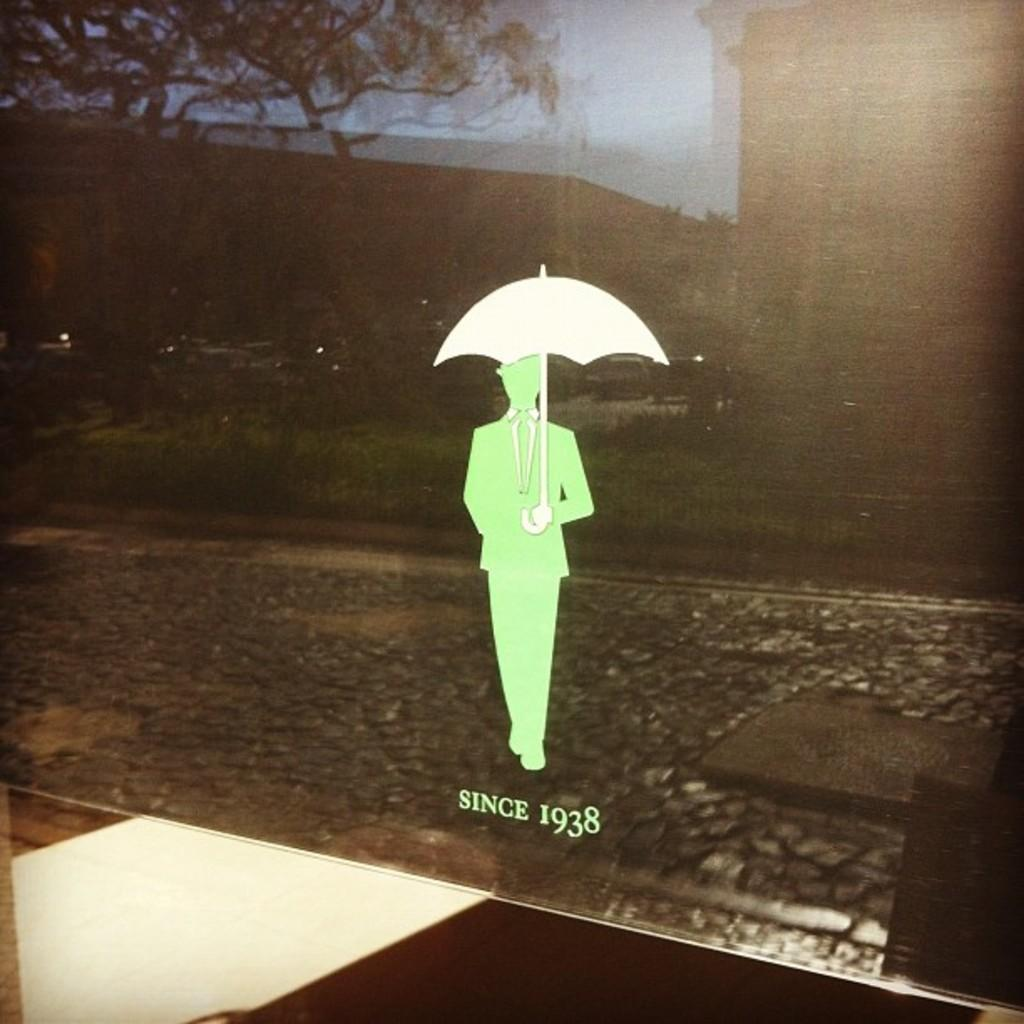What is the main subject of the animated image in the middle of the picture? There is an animated image of a person holding an umbrella in the middle of the image. What can be seen in the background of the image? There are trees and vehicles in the background of the image. How does the fog affect the visibility of the horses in the image? There are no horses or fog present in the image. What type of powder is being used by the person holding the umbrella in the image? There is no powder visible in the image; the person is holding an umbrella. 